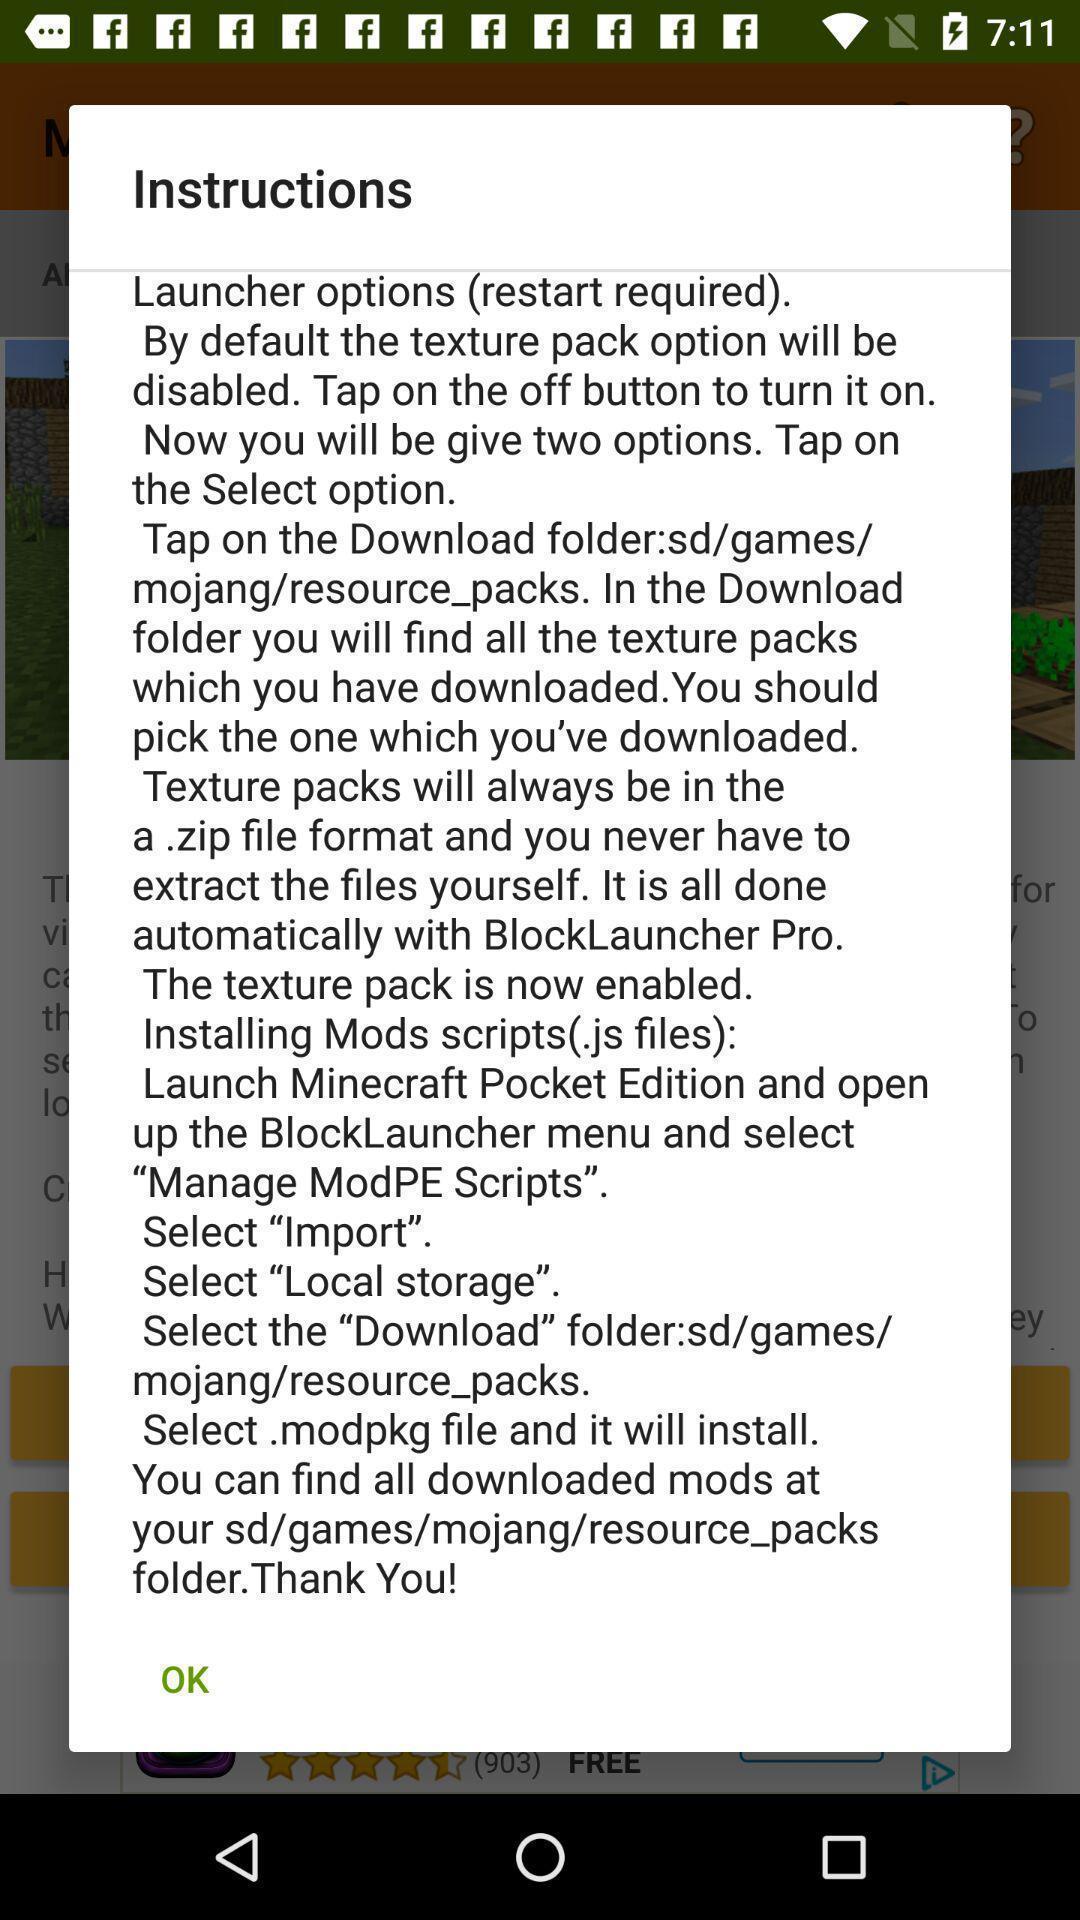Describe the visual elements of this screenshot. Popup showing about instructions with ok option. 